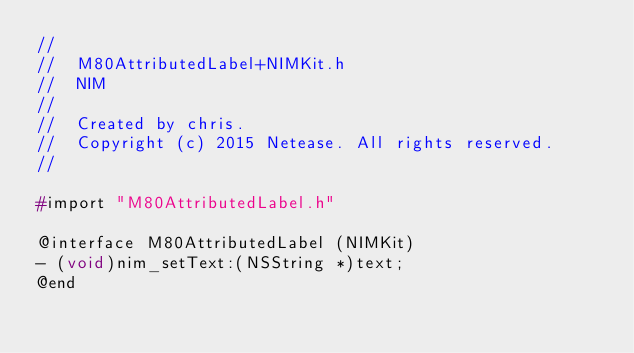Convert code to text. <code><loc_0><loc_0><loc_500><loc_500><_C_>//
//  M80AttributedLabel+NIMKit.h
//  NIM
//
//  Created by chris.
//  Copyright (c) 2015 Netease. All rights reserved.
//

#import "M80AttributedLabel.h"

@interface M80AttributedLabel (NIMKit)
- (void)nim_setText:(NSString *)text;
@end
</code> 